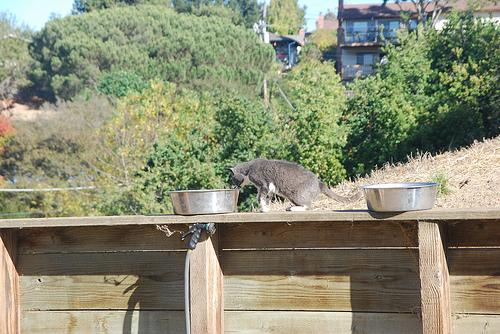Identify the main focus of the image and what they are doing. The main focus is a grey and white cat that is drinking water from a metal bowl on a porch. What is the principal subject in the image and what task are they performing? The principal subject is a grey and white cat, and it is performing the task of drinking water. Give a concise description of the central object and action in the image. The central object is a grey and white cat, which is drinking water from a bowl on a porch. Identify the main object in the image and describe its color and activity. The main object is a grey and white cat, drinking water on the porch. Analyze the image and provide a description of the primary animal and its action. The primary animal is a grey and white cat engaged in drinking water from a metal bowl. Examine the image and determine how many distinct objects are captured and what they're doing. There are 3 key objects: a grey and white cat drinking water, a shiny silver bowl it's drinking from, and a wooden-paneled gate. Give a brief summary of the primary action taking place in the image. A grey and white cat is drinking water from a bowl on a porch. Please describe the environment and what the central character in the image is engaged in. The setting is a porch with wooden elements, and the central character is a grey and white cat drinking water. Observe the image and explain the main scene displayed. The main scene displayed is a grey and white cat drinking water from a shiny silver bowl on a wooden-paneled porch. Describe the primary situation taking place in the image and the main character involved. The primary situation is a grey and white cat drinking water from a bowl on a porch with wooden elements. 